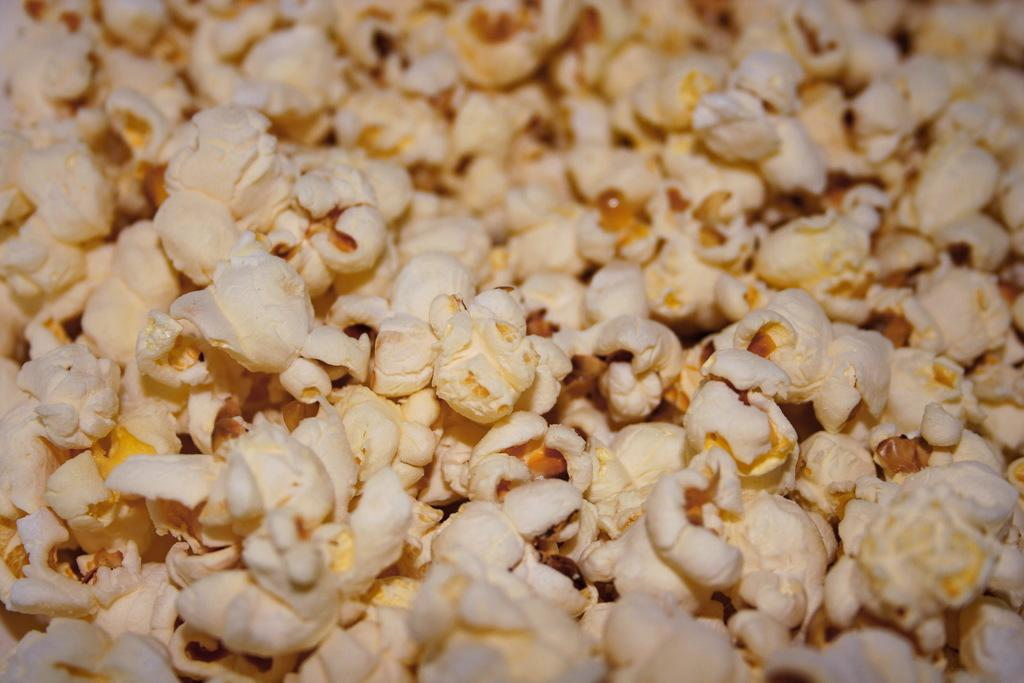What type of food is present in the image? There are popcorns in the image. Where is the map stored in the image? There is no map present in the image. What type of furniture is the drawer located in the image? There is no drawer present in the image. What is the condition of the sidewalk in the image? There is no sidewalk present in the image. 